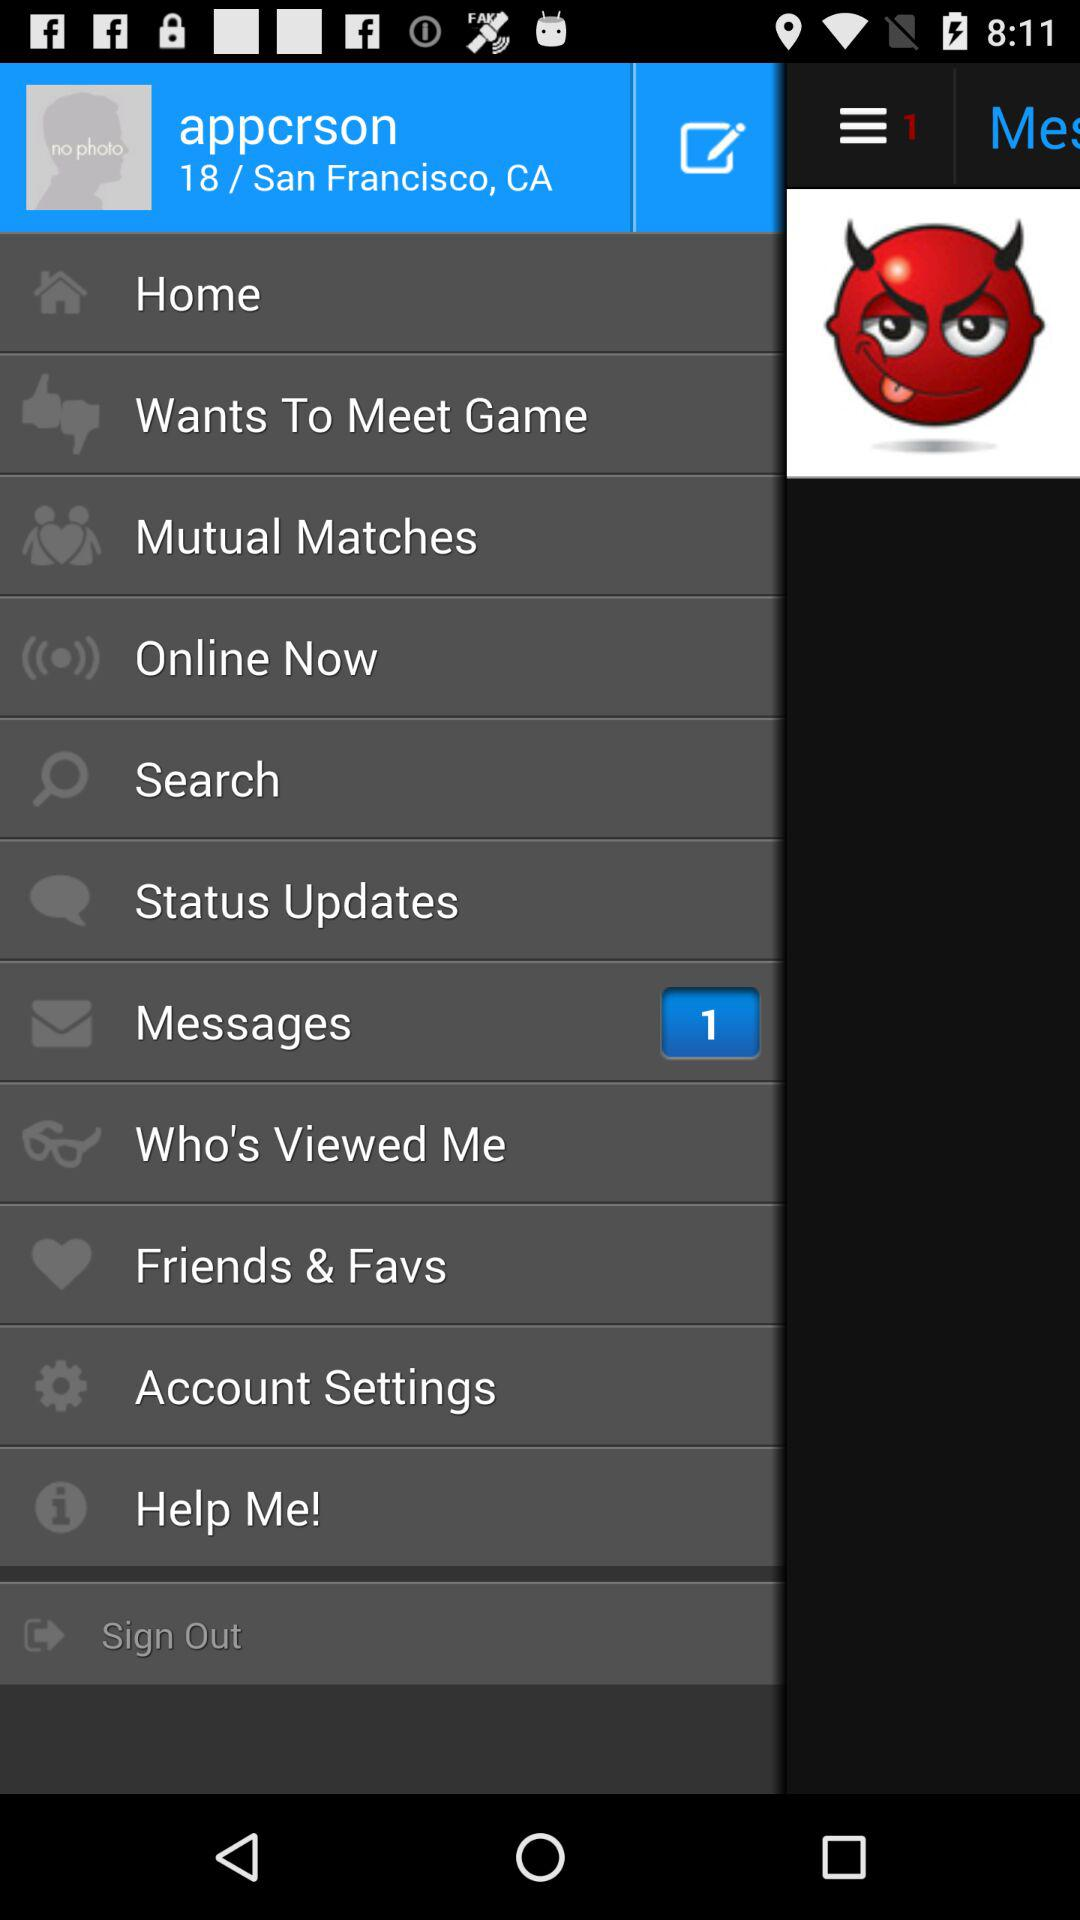How many unread messages are there? There is 1 unread message. 